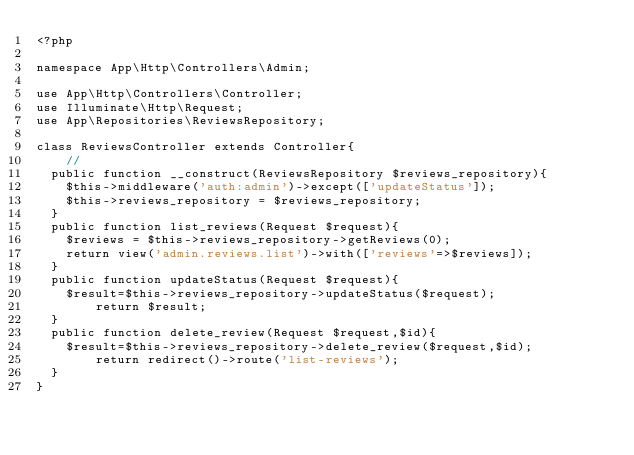Convert code to text. <code><loc_0><loc_0><loc_500><loc_500><_PHP_><?php

namespace App\Http\Controllers\Admin;

use App\Http\Controllers\Controller;
use Illuminate\Http\Request;
use App\Repositories\ReviewsRepository;

class ReviewsController extends Controller{
    //
	public function __construct(ReviewsRepository $reviews_repository){
		$this->middleware('auth:admin')->except(['updateStatus']);
		$this->reviews_repository = $reviews_repository;
	}
	public function list_reviews(Request $request){
		$reviews = $this->reviews_repository->getReviews(0);
		return view('admin.reviews.list')->with(['reviews'=>$reviews]);
	}
	public function updateStatus(Request $request){
		$result=$this->reviews_repository->updateStatus($request);
        return $result;
	}
	public function delete_review(Request $request,$id){
		$result=$this->reviews_repository->delete_review($request,$id);
        return redirect()->route('list-reviews');
	}
}
</code> 